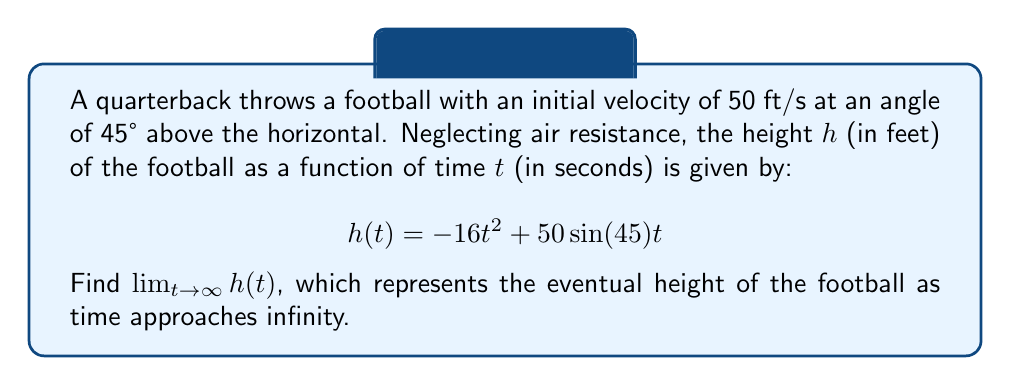Could you help me with this problem? To find the limit of $h(t)$ as $t$ approaches infinity, let's follow these steps:

1) First, let's simplify the function by calculating $\sin(45°)$:
   $\sin(45°) = \frac{\sqrt{2}}{2}$

   So, our function becomes:
   $$h(t) = -16t^2 + 50\frac{\sqrt{2}}{2}t = -16t^2 + 25\sqrt{2}t$$

2) Now, we need to analyze the behavior of this function as $t$ approaches infinity. We can do this by looking at the degrees of the terms:

   - The term $-16t^2$ is of degree 2
   - The term $25\sqrt{2}t$ is of degree 1

3) As $t$ becomes very large, the term with the highest degree will dominate. In this case, it's the $-16t^2$ term.

4) The coefficient of the dominant term is negative (-16), which means that as $t$ approaches infinity, $h(t)$ will approach negative infinity.

5) We can express this mathematically as:

   $$\lim_{t \to \infty} h(t) = \lim_{t \to \infty} (-16t^2 + 25\sqrt{2}t) = -\infty$$

This result makes sense in the context of a football trajectory. After reaching its peak height, the football will fall back towards the ground, eventually going below the initial throwing height (which we've set as 0 in this model) if we consider an infinitely large field.
Answer: $\lim_{t \to \infty} h(t) = -\infty$ 